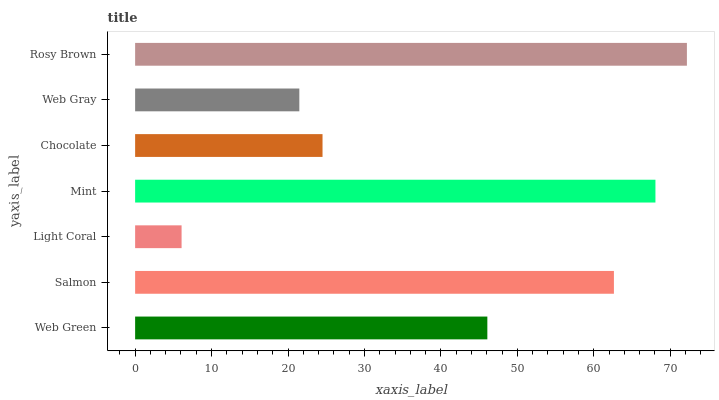Is Light Coral the minimum?
Answer yes or no. Yes. Is Rosy Brown the maximum?
Answer yes or no. Yes. Is Salmon the minimum?
Answer yes or no. No. Is Salmon the maximum?
Answer yes or no. No. Is Salmon greater than Web Green?
Answer yes or no. Yes. Is Web Green less than Salmon?
Answer yes or no. Yes. Is Web Green greater than Salmon?
Answer yes or no. No. Is Salmon less than Web Green?
Answer yes or no. No. Is Web Green the high median?
Answer yes or no. Yes. Is Web Green the low median?
Answer yes or no. Yes. Is Web Gray the high median?
Answer yes or no. No. Is Chocolate the low median?
Answer yes or no. No. 